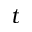<formula> <loc_0><loc_0><loc_500><loc_500>t</formula> 